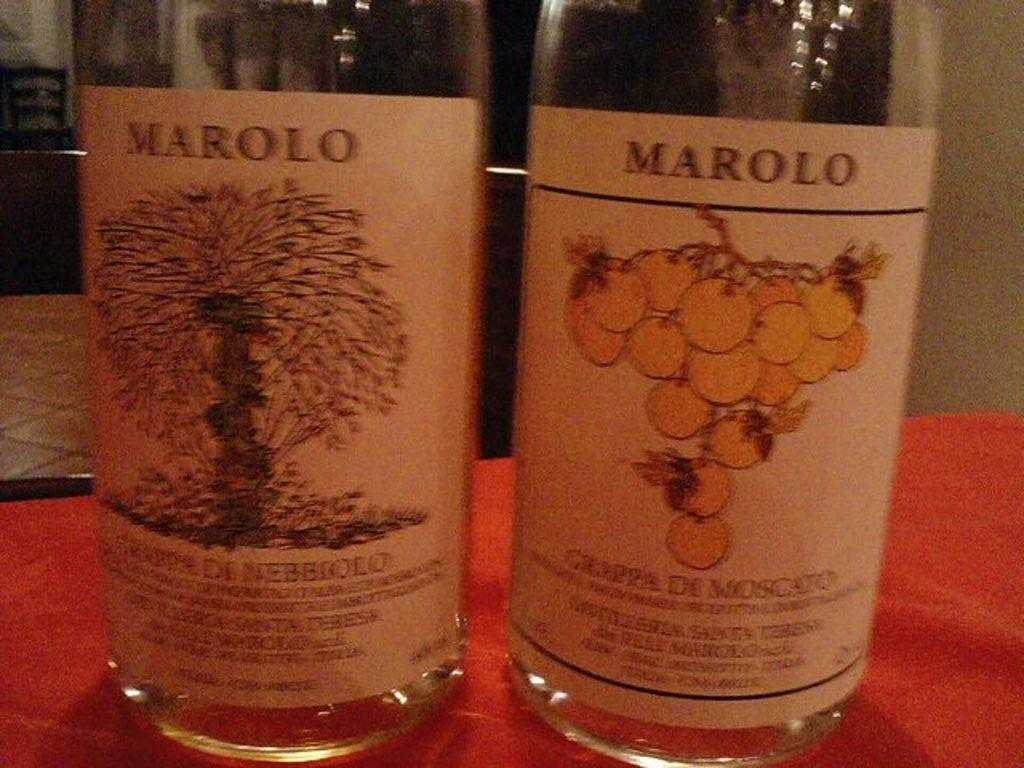<image>
Share a concise interpretation of the image provided. Marolo Grappe De Moscato wine bottles sit on a table side by side. 